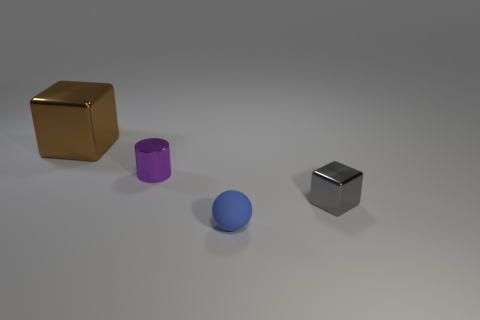Add 2 large cyan rubber blocks. How many objects exist? 6 Subtract all spheres. How many objects are left? 3 Subtract 0 red blocks. How many objects are left? 4 Subtract all purple metal cylinders. Subtract all cyan cubes. How many objects are left? 3 Add 3 big things. How many big things are left? 4 Add 4 green metal things. How many green metal things exist? 4 